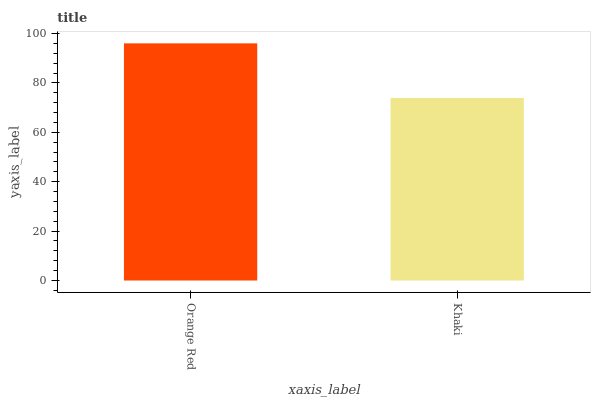Is Khaki the minimum?
Answer yes or no. Yes. Is Orange Red the maximum?
Answer yes or no. Yes. Is Khaki the maximum?
Answer yes or no. No. Is Orange Red greater than Khaki?
Answer yes or no. Yes. Is Khaki less than Orange Red?
Answer yes or no. Yes. Is Khaki greater than Orange Red?
Answer yes or no. No. Is Orange Red less than Khaki?
Answer yes or no. No. Is Orange Red the high median?
Answer yes or no. Yes. Is Khaki the low median?
Answer yes or no. Yes. Is Khaki the high median?
Answer yes or no. No. Is Orange Red the low median?
Answer yes or no. No. 